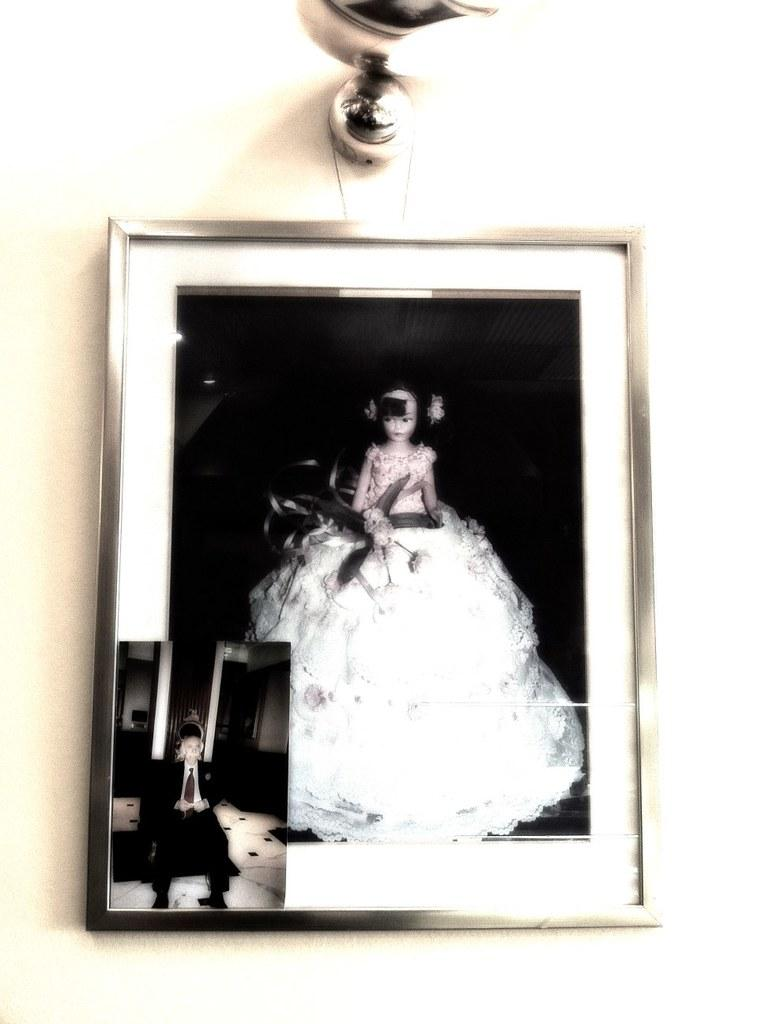What object can be seen in the image that is used for displaying photos? There is a photo frame in the image. Where is the photo frame located in the image? The photo frame is on the wall. What else can be seen on the wall in the image? There is a light on the wall in the image. What type of carriage is depicted in the photo frame in the image? There is no carriage depicted in the photo frame in the image, as the photo frame is empty or not visible in the image. 